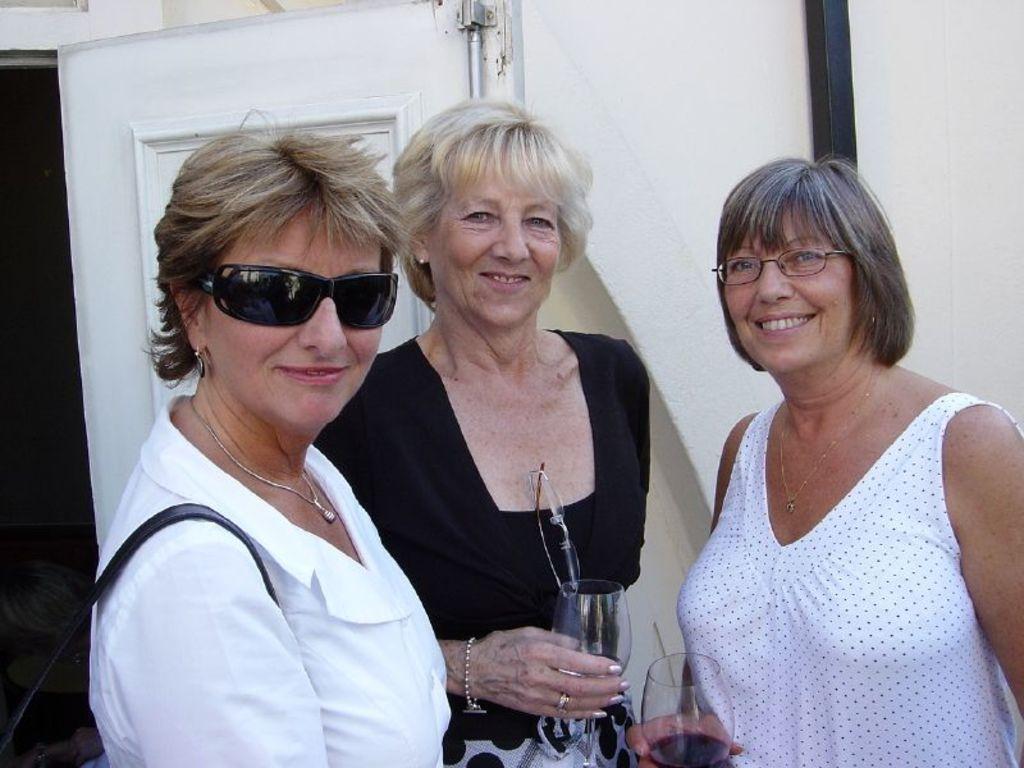In one or two sentences, can you explain what this image depicts? In this image we can see three women wearing dress are standing. one woman is wearing goggles and carrying a bag. Two women are holding glasses in their hands. In the background, we can see a building with metal pole and a door. 